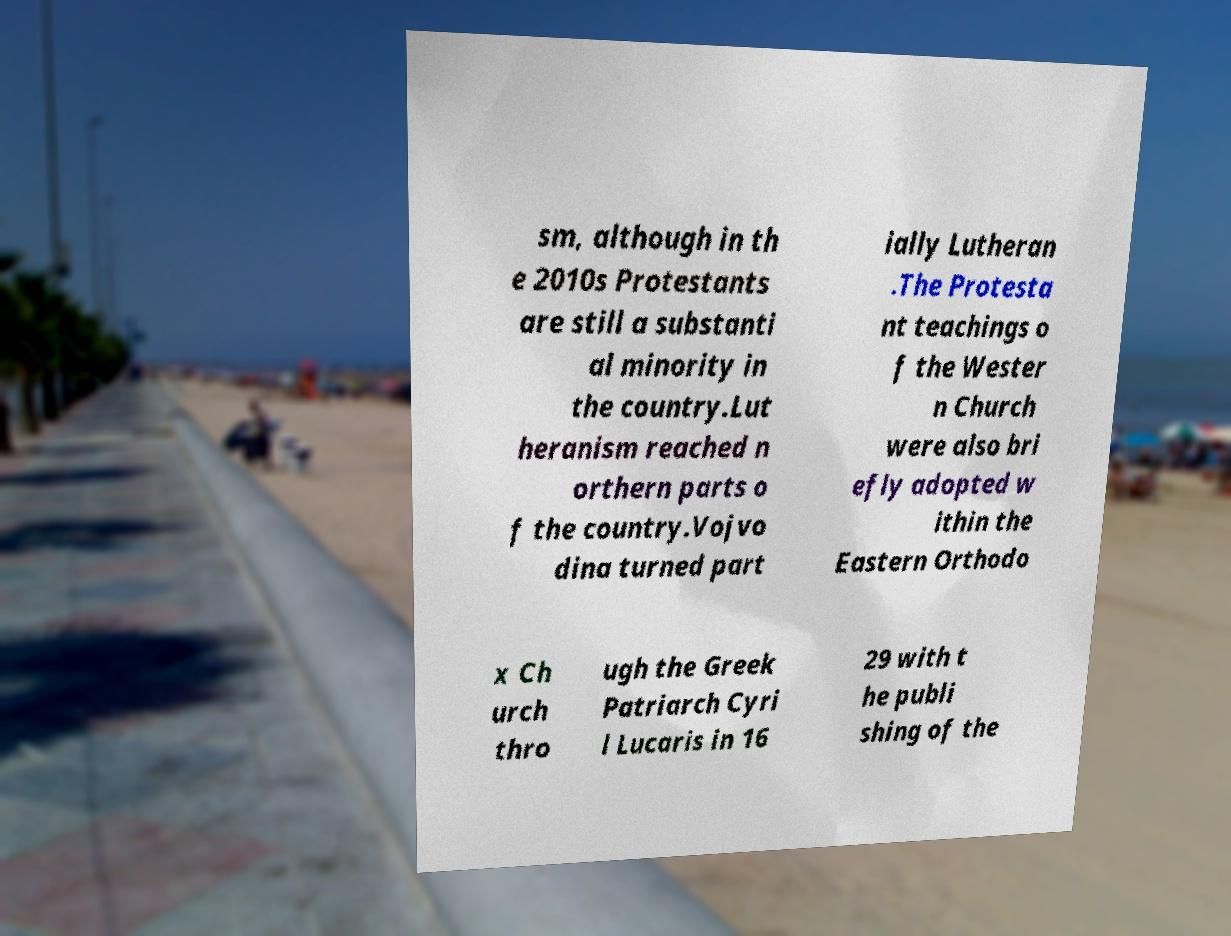Please read and relay the text visible in this image. What does it say? sm, although in th e 2010s Protestants are still a substanti al minority in the country.Lut heranism reached n orthern parts o f the country.Vojvo dina turned part ially Lutheran .The Protesta nt teachings o f the Wester n Church were also bri efly adopted w ithin the Eastern Orthodo x Ch urch thro ugh the Greek Patriarch Cyri l Lucaris in 16 29 with t he publi shing of the 